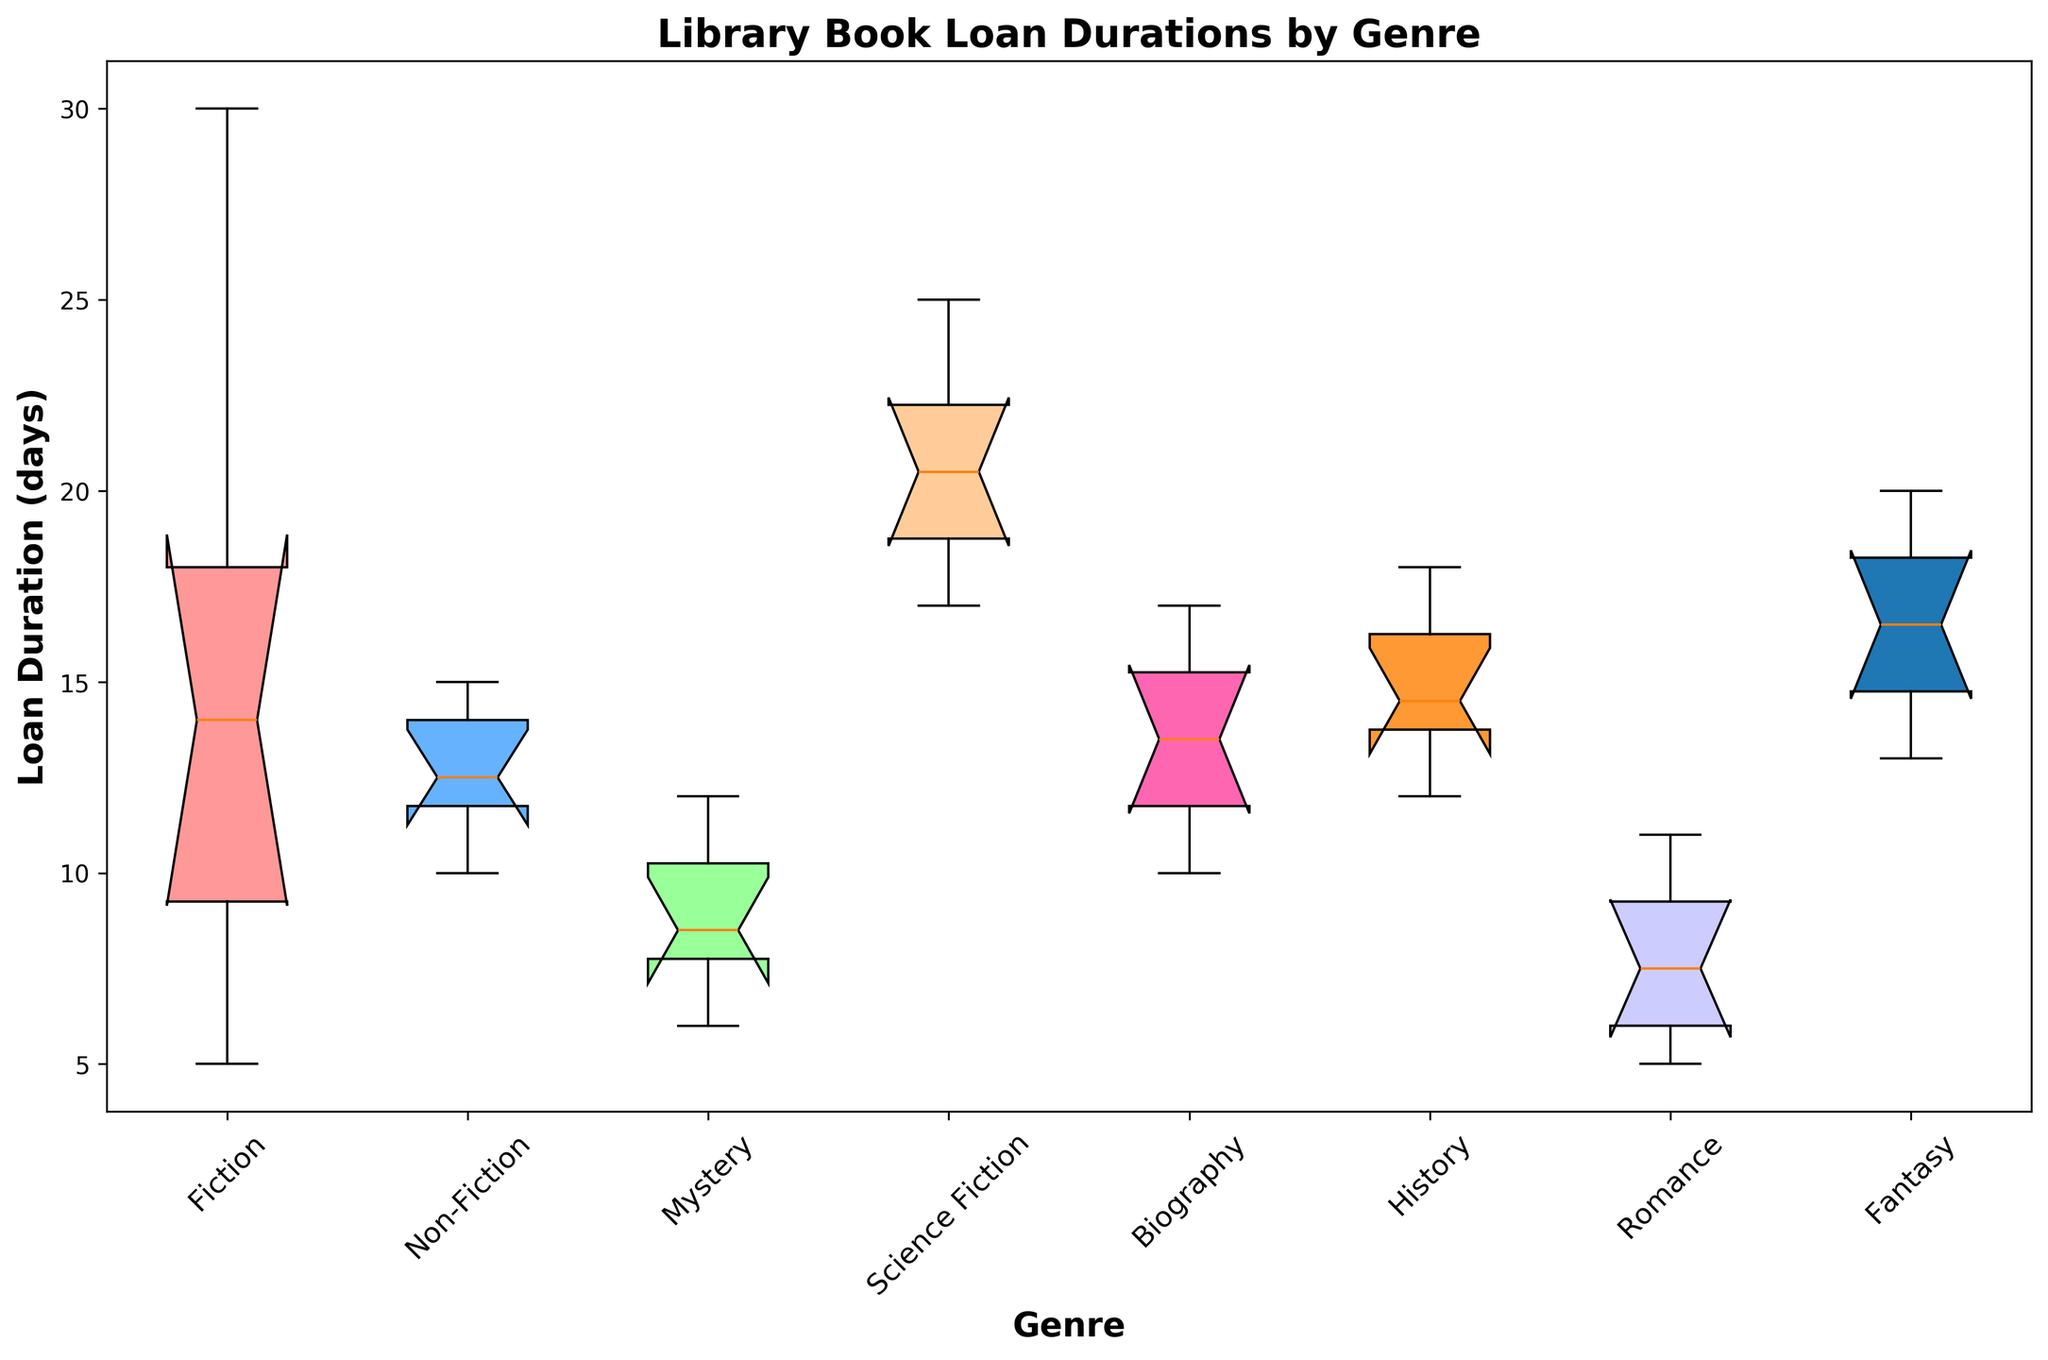What are the median loan durations for each genre? To find the median loan duration for each genre, locate the middle line within each box plot, which represents the median value.
Answer: Fiction: 14 days, Non-Fiction: 13 days, Mystery: 8.5 days, Science Fiction: 20.5 days, Biography: 13 days, History: 14.5 days, Romance: 7 days, Fantasy: 16.5 days Which genre has the longest loan duration for a single book? Look for the highest point in the plot (i.e., the top whisker) which represents the maximum value for all genres.
Answer: Fiction: 30 days Which genre has the shortest loan duration for a single book? Look for the lowest point in the plot (i.e., the bottom whisker) which represents the minimum value for all genres.
Answer: Fiction and Romance: 5 days Is the variability of loan durations higher in Fiction or Mystery? Compare the lengths of the boxes and whiskers. The longer these elements are, the greater the variability. The Fiction genre has a larger interquartile range and longer whiskers compared to Mystery.
Answer: Fiction How do the median loan durations of Science Fiction and Non-Fiction compare? Compare the positions of the middle lines within the boxes of Science Fiction and Non-Fiction. Science Fiction's median (20.5 days) is noticeably higher than Non-Fiction's median (13 days).
Answer: Science Fiction is greater What color represents the Romance genre's data in the box plot? Identify the color used for the Romance genre by noting which color aligns with the label "Romance" at the bottom of the box plot.
Answer: Pink Which genre has the least median loan duration and how much is it? Locate the genre with the lowest middle line of the box, representing the median. The Romance genre has the lowest median loan duration.
Answer: Romance: 7 days Which genres have identical medians? Check the positions of the middle lines within the boxes. Both Non-Fiction and Biography share the same median value.
Answer: Non-Fiction and Biography: 13 days Is the interquartile range (IQR) larger for Fantasy or Biography? Compare the lengths of the boxes, which represent the IQR. Fantasy's box is visibly longer than Biography's, indicating a larger IQR.
Answer: Fantasy 